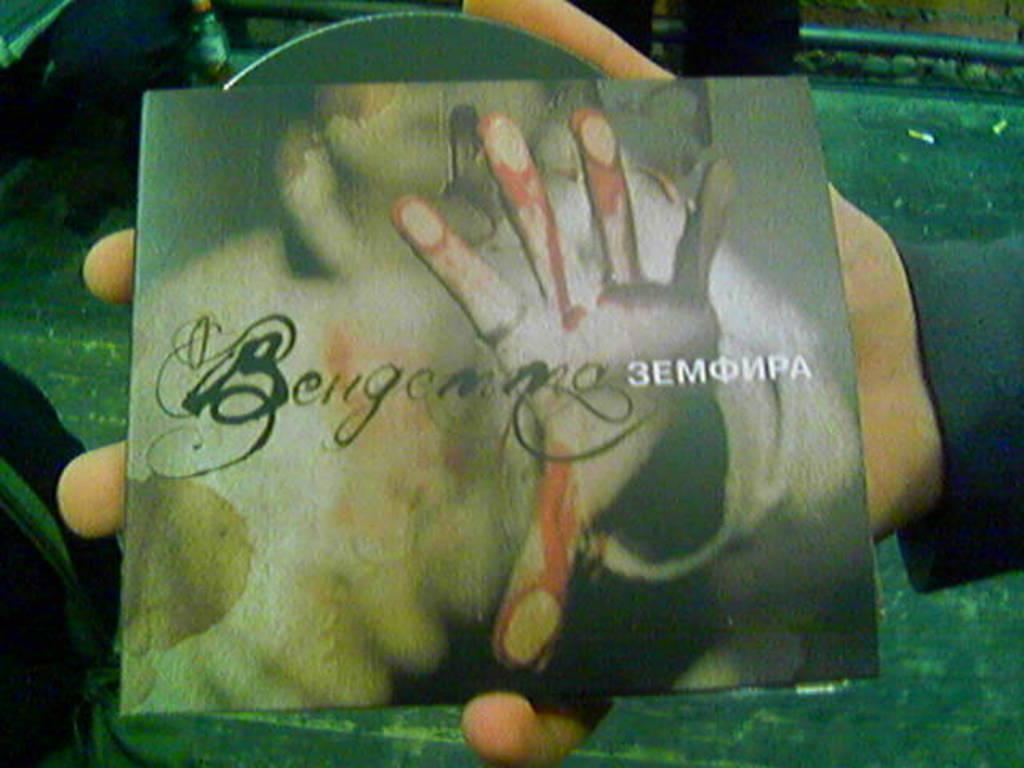Please provide a concise description of this image. In this picture there is a person's hand holding a cd cover. Below the hand there is a table, on the table there are few objects. At the top right there is a brick wall. 